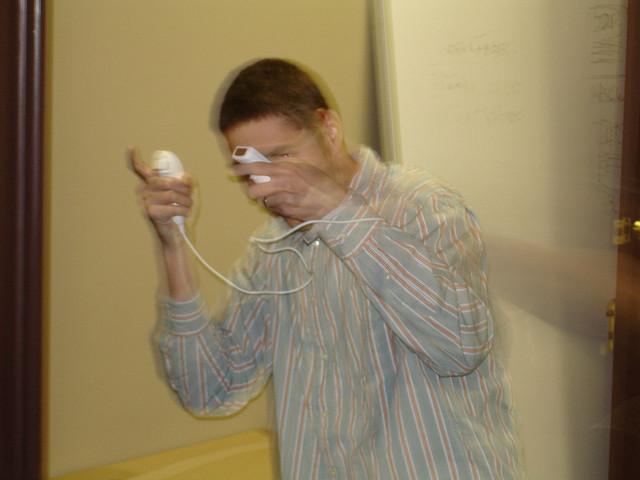Why does the man look blurry?
Concise answer only. Moving. What is the man holding in his hands?
Concise answer only. Wii controller. What is the pattern of the man's shirt?
Concise answer only. Striped. 